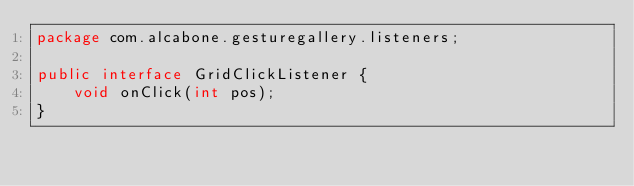Convert code to text. <code><loc_0><loc_0><loc_500><loc_500><_Java_>package com.alcabone.gesturegallery.listeners;

public interface GridClickListener {
    void onClick(int pos);
}
</code> 